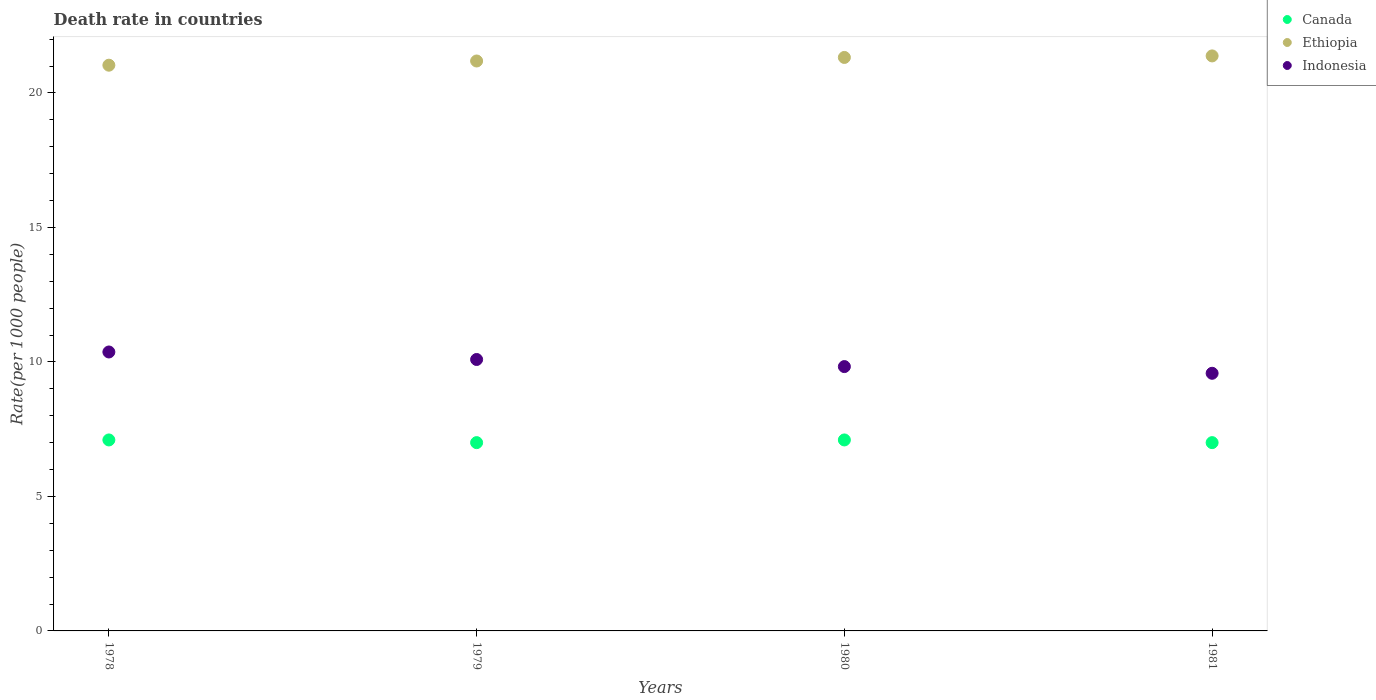What is the death rate in Canada in 1981?
Keep it short and to the point. 7. Across all years, what is the maximum death rate in Ethiopia?
Provide a succinct answer. 21.38. Across all years, what is the minimum death rate in Canada?
Provide a short and direct response. 7. In which year was the death rate in Canada minimum?
Give a very brief answer. 1979. What is the total death rate in Indonesia in the graph?
Provide a succinct answer. 39.87. What is the difference between the death rate in Canada in 1980 and that in 1981?
Your answer should be compact. 0.1. What is the difference between the death rate in Ethiopia in 1979 and the death rate in Canada in 1978?
Make the answer very short. 14.09. What is the average death rate in Canada per year?
Your answer should be compact. 7.05. In the year 1978, what is the difference between the death rate in Canada and death rate in Indonesia?
Your answer should be compact. -3.27. In how many years, is the death rate in Canada greater than 9?
Provide a short and direct response. 0. What is the ratio of the death rate in Indonesia in 1978 to that in 1979?
Provide a short and direct response. 1.03. Is the difference between the death rate in Canada in 1978 and 1980 greater than the difference between the death rate in Indonesia in 1978 and 1980?
Give a very brief answer. No. What is the difference between the highest and the second highest death rate in Indonesia?
Make the answer very short. 0.28. What is the difference between the highest and the lowest death rate in Ethiopia?
Give a very brief answer. 0.34. In how many years, is the death rate in Ethiopia greater than the average death rate in Ethiopia taken over all years?
Your response must be concise. 2. Is it the case that in every year, the sum of the death rate in Canada and death rate in Indonesia  is greater than the death rate in Ethiopia?
Offer a very short reply. No. Is the death rate in Ethiopia strictly less than the death rate in Canada over the years?
Give a very brief answer. No. How many dotlines are there?
Ensure brevity in your answer.  3. What is the difference between two consecutive major ticks on the Y-axis?
Offer a terse response. 5. Are the values on the major ticks of Y-axis written in scientific E-notation?
Offer a terse response. No. Does the graph contain grids?
Keep it short and to the point. No. How many legend labels are there?
Offer a very short reply. 3. What is the title of the graph?
Your answer should be compact. Death rate in countries. What is the label or title of the X-axis?
Ensure brevity in your answer.  Years. What is the label or title of the Y-axis?
Offer a very short reply. Rate(per 1000 people). What is the Rate(per 1000 people) of Canada in 1978?
Your answer should be very brief. 7.1. What is the Rate(per 1000 people) of Ethiopia in 1978?
Your response must be concise. 21.03. What is the Rate(per 1000 people) in Indonesia in 1978?
Keep it short and to the point. 10.37. What is the Rate(per 1000 people) of Canada in 1979?
Your answer should be very brief. 7. What is the Rate(per 1000 people) of Ethiopia in 1979?
Provide a short and direct response. 21.19. What is the Rate(per 1000 people) of Indonesia in 1979?
Ensure brevity in your answer.  10.09. What is the Rate(per 1000 people) of Canada in 1980?
Your answer should be compact. 7.1. What is the Rate(per 1000 people) in Ethiopia in 1980?
Offer a very short reply. 21.32. What is the Rate(per 1000 people) in Indonesia in 1980?
Give a very brief answer. 9.83. What is the Rate(per 1000 people) in Canada in 1981?
Your answer should be very brief. 7. What is the Rate(per 1000 people) in Ethiopia in 1981?
Your answer should be compact. 21.38. What is the Rate(per 1000 people) of Indonesia in 1981?
Give a very brief answer. 9.58. Across all years, what is the maximum Rate(per 1000 people) of Ethiopia?
Keep it short and to the point. 21.38. Across all years, what is the maximum Rate(per 1000 people) in Indonesia?
Your answer should be very brief. 10.37. Across all years, what is the minimum Rate(per 1000 people) in Canada?
Give a very brief answer. 7. Across all years, what is the minimum Rate(per 1000 people) in Ethiopia?
Offer a very short reply. 21.03. Across all years, what is the minimum Rate(per 1000 people) of Indonesia?
Make the answer very short. 9.58. What is the total Rate(per 1000 people) in Canada in the graph?
Give a very brief answer. 28.2. What is the total Rate(per 1000 people) in Ethiopia in the graph?
Make the answer very short. 84.92. What is the total Rate(per 1000 people) in Indonesia in the graph?
Your answer should be compact. 39.87. What is the difference between the Rate(per 1000 people) of Canada in 1978 and that in 1979?
Make the answer very short. 0.1. What is the difference between the Rate(per 1000 people) of Ethiopia in 1978 and that in 1979?
Provide a succinct answer. -0.16. What is the difference between the Rate(per 1000 people) of Indonesia in 1978 and that in 1979?
Offer a terse response. 0.28. What is the difference between the Rate(per 1000 people) in Canada in 1978 and that in 1980?
Offer a very short reply. 0. What is the difference between the Rate(per 1000 people) of Ethiopia in 1978 and that in 1980?
Give a very brief answer. -0.29. What is the difference between the Rate(per 1000 people) in Indonesia in 1978 and that in 1980?
Ensure brevity in your answer.  0.54. What is the difference between the Rate(per 1000 people) of Ethiopia in 1978 and that in 1981?
Offer a terse response. -0.34. What is the difference between the Rate(per 1000 people) in Indonesia in 1978 and that in 1981?
Your response must be concise. 0.79. What is the difference between the Rate(per 1000 people) in Canada in 1979 and that in 1980?
Offer a terse response. -0.1. What is the difference between the Rate(per 1000 people) of Ethiopia in 1979 and that in 1980?
Provide a succinct answer. -0.13. What is the difference between the Rate(per 1000 people) in Indonesia in 1979 and that in 1980?
Offer a terse response. 0.26. What is the difference between the Rate(per 1000 people) in Canada in 1979 and that in 1981?
Provide a succinct answer. 0. What is the difference between the Rate(per 1000 people) in Ethiopia in 1979 and that in 1981?
Make the answer very short. -0.19. What is the difference between the Rate(per 1000 people) in Indonesia in 1979 and that in 1981?
Make the answer very short. 0.51. What is the difference between the Rate(per 1000 people) of Canada in 1980 and that in 1981?
Ensure brevity in your answer.  0.1. What is the difference between the Rate(per 1000 people) in Ethiopia in 1980 and that in 1981?
Provide a succinct answer. -0.06. What is the difference between the Rate(per 1000 people) of Indonesia in 1980 and that in 1981?
Provide a short and direct response. 0.25. What is the difference between the Rate(per 1000 people) of Canada in 1978 and the Rate(per 1000 people) of Ethiopia in 1979?
Your response must be concise. -14.09. What is the difference between the Rate(per 1000 people) of Canada in 1978 and the Rate(per 1000 people) of Indonesia in 1979?
Provide a short and direct response. -2.99. What is the difference between the Rate(per 1000 people) of Ethiopia in 1978 and the Rate(per 1000 people) of Indonesia in 1979?
Your answer should be compact. 10.94. What is the difference between the Rate(per 1000 people) of Canada in 1978 and the Rate(per 1000 people) of Ethiopia in 1980?
Ensure brevity in your answer.  -14.22. What is the difference between the Rate(per 1000 people) of Canada in 1978 and the Rate(per 1000 people) of Indonesia in 1980?
Ensure brevity in your answer.  -2.73. What is the difference between the Rate(per 1000 people) of Ethiopia in 1978 and the Rate(per 1000 people) of Indonesia in 1980?
Provide a short and direct response. 11.21. What is the difference between the Rate(per 1000 people) in Canada in 1978 and the Rate(per 1000 people) in Ethiopia in 1981?
Offer a very short reply. -14.28. What is the difference between the Rate(per 1000 people) of Canada in 1978 and the Rate(per 1000 people) of Indonesia in 1981?
Your response must be concise. -2.48. What is the difference between the Rate(per 1000 people) of Ethiopia in 1978 and the Rate(per 1000 people) of Indonesia in 1981?
Ensure brevity in your answer.  11.45. What is the difference between the Rate(per 1000 people) in Canada in 1979 and the Rate(per 1000 people) in Ethiopia in 1980?
Offer a terse response. -14.32. What is the difference between the Rate(per 1000 people) of Canada in 1979 and the Rate(per 1000 people) of Indonesia in 1980?
Offer a terse response. -2.83. What is the difference between the Rate(per 1000 people) in Ethiopia in 1979 and the Rate(per 1000 people) in Indonesia in 1980?
Provide a short and direct response. 11.36. What is the difference between the Rate(per 1000 people) in Canada in 1979 and the Rate(per 1000 people) in Ethiopia in 1981?
Give a very brief answer. -14.38. What is the difference between the Rate(per 1000 people) in Canada in 1979 and the Rate(per 1000 people) in Indonesia in 1981?
Give a very brief answer. -2.58. What is the difference between the Rate(per 1000 people) in Ethiopia in 1979 and the Rate(per 1000 people) in Indonesia in 1981?
Provide a succinct answer. 11.61. What is the difference between the Rate(per 1000 people) of Canada in 1980 and the Rate(per 1000 people) of Ethiopia in 1981?
Provide a succinct answer. -14.28. What is the difference between the Rate(per 1000 people) in Canada in 1980 and the Rate(per 1000 people) in Indonesia in 1981?
Ensure brevity in your answer.  -2.48. What is the difference between the Rate(per 1000 people) of Ethiopia in 1980 and the Rate(per 1000 people) of Indonesia in 1981?
Your answer should be very brief. 11.74. What is the average Rate(per 1000 people) in Canada per year?
Your answer should be compact. 7.05. What is the average Rate(per 1000 people) of Ethiopia per year?
Make the answer very short. 21.23. What is the average Rate(per 1000 people) in Indonesia per year?
Offer a very short reply. 9.97. In the year 1978, what is the difference between the Rate(per 1000 people) of Canada and Rate(per 1000 people) of Ethiopia?
Your response must be concise. -13.93. In the year 1978, what is the difference between the Rate(per 1000 people) in Canada and Rate(per 1000 people) in Indonesia?
Your response must be concise. -3.27. In the year 1978, what is the difference between the Rate(per 1000 people) of Ethiopia and Rate(per 1000 people) of Indonesia?
Give a very brief answer. 10.66. In the year 1979, what is the difference between the Rate(per 1000 people) of Canada and Rate(per 1000 people) of Ethiopia?
Make the answer very short. -14.19. In the year 1979, what is the difference between the Rate(per 1000 people) of Canada and Rate(per 1000 people) of Indonesia?
Keep it short and to the point. -3.09. In the year 1979, what is the difference between the Rate(per 1000 people) of Ethiopia and Rate(per 1000 people) of Indonesia?
Offer a terse response. 11.1. In the year 1980, what is the difference between the Rate(per 1000 people) of Canada and Rate(per 1000 people) of Ethiopia?
Provide a succinct answer. -14.22. In the year 1980, what is the difference between the Rate(per 1000 people) in Canada and Rate(per 1000 people) in Indonesia?
Offer a terse response. -2.73. In the year 1980, what is the difference between the Rate(per 1000 people) of Ethiopia and Rate(per 1000 people) of Indonesia?
Provide a short and direct response. 11.49. In the year 1981, what is the difference between the Rate(per 1000 people) in Canada and Rate(per 1000 people) in Ethiopia?
Ensure brevity in your answer.  -14.38. In the year 1981, what is the difference between the Rate(per 1000 people) in Canada and Rate(per 1000 people) in Indonesia?
Offer a very short reply. -2.58. In the year 1981, what is the difference between the Rate(per 1000 people) in Ethiopia and Rate(per 1000 people) in Indonesia?
Keep it short and to the point. 11.8. What is the ratio of the Rate(per 1000 people) of Canada in 1978 to that in 1979?
Your answer should be very brief. 1.01. What is the ratio of the Rate(per 1000 people) in Ethiopia in 1978 to that in 1979?
Make the answer very short. 0.99. What is the ratio of the Rate(per 1000 people) in Indonesia in 1978 to that in 1979?
Give a very brief answer. 1.03. What is the ratio of the Rate(per 1000 people) of Canada in 1978 to that in 1980?
Ensure brevity in your answer.  1. What is the ratio of the Rate(per 1000 people) of Ethiopia in 1978 to that in 1980?
Make the answer very short. 0.99. What is the ratio of the Rate(per 1000 people) in Indonesia in 1978 to that in 1980?
Offer a terse response. 1.06. What is the ratio of the Rate(per 1000 people) in Canada in 1978 to that in 1981?
Give a very brief answer. 1.01. What is the ratio of the Rate(per 1000 people) of Ethiopia in 1978 to that in 1981?
Provide a short and direct response. 0.98. What is the ratio of the Rate(per 1000 people) in Indonesia in 1978 to that in 1981?
Your response must be concise. 1.08. What is the ratio of the Rate(per 1000 people) in Canada in 1979 to that in 1980?
Give a very brief answer. 0.99. What is the ratio of the Rate(per 1000 people) in Indonesia in 1979 to that in 1980?
Keep it short and to the point. 1.03. What is the ratio of the Rate(per 1000 people) of Canada in 1979 to that in 1981?
Provide a succinct answer. 1. What is the ratio of the Rate(per 1000 people) of Indonesia in 1979 to that in 1981?
Your answer should be very brief. 1.05. What is the ratio of the Rate(per 1000 people) in Canada in 1980 to that in 1981?
Provide a succinct answer. 1.01. What is the ratio of the Rate(per 1000 people) of Ethiopia in 1980 to that in 1981?
Keep it short and to the point. 1. What is the difference between the highest and the second highest Rate(per 1000 people) of Canada?
Offer a terse response. 0. What is the difference between the highest and the second highest Rate(per 1000 people) in Ethiopia?
Your response must be concise. 0.06. What is the difference between the highest and the second highest Rate(per 1000 people) in Indonesia?
Your response must be concise. 0.28. What is the difference between the highest and the lowest Rate(per 1000 people) in Canada?
Keep it short and to the point. 0.1. What is the difference between the highest and the lowest Rate(per 1000 people) in Ethiopia?
Your answer should be compact. 0.34. What is the difference between the highest and the lowest Rate(per 1000 people) of Indonesia?
Offer a very short reply. 0.79. 